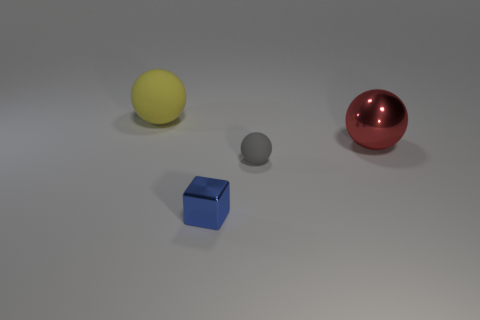Subtract all red metallic spheres. How many spheres are left? 2 Subtract all cubes. How many objects are left? 3 Subtract 2 balls. How many balls are left? 1 Add 3 tiny cyan matte balls. How many objects exist? 7 Subtract all gray spheres. How many spheres are left? 2 Subtract all blue spheres. Subtract all purple cylinders. How many spheres are left? 3 Subtract all gray matte objects. Subtract all tiny shiny objects. How many objects are left? 2 Add 1 small blue objects. How many small blue objects are left? 2 Add 2 big green cylinders. How many big green cylinders exist? 2 Subtract 0 green balls. How many objects are left? 4 